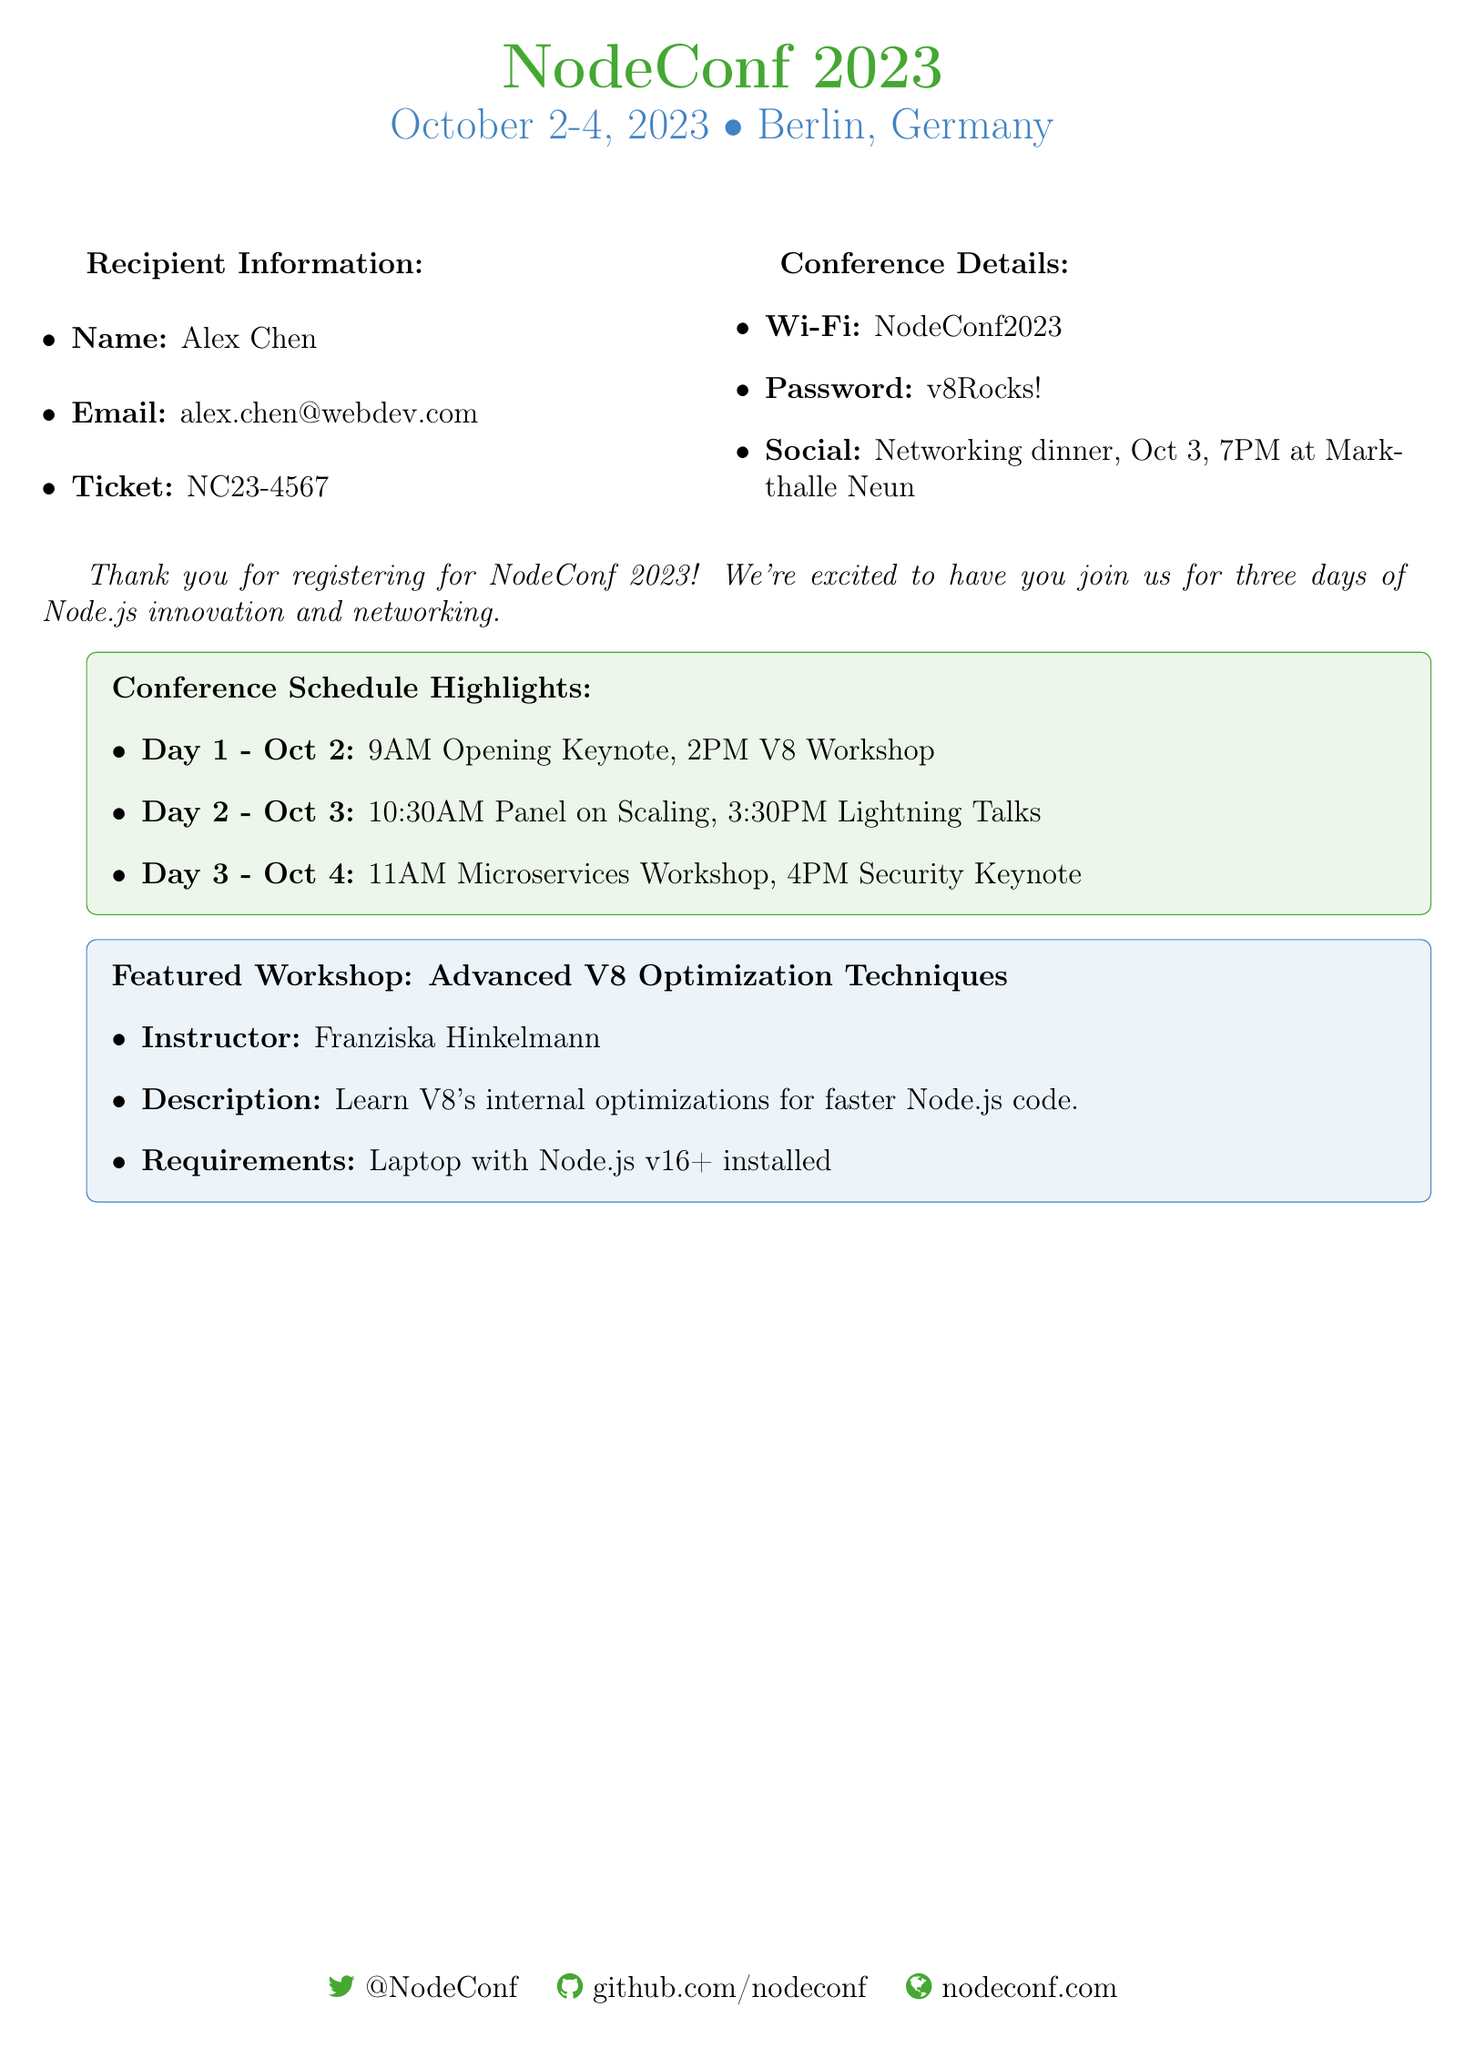What are the dates of the conference? The dates of the conference are explicitly stated at the top of the document as October 2-4, 2023.
Answer: October 2-4, 2023 What is the recipient's email address? The email address of the recipient is listed in the recipient information section.
Answer: alex.chen@webdev.com What is the ticket number? The ticket number for the recipient is clearly mentioned in the document.
Answer: NC23-4567 What is the name of the workshop featured? The document mentions the featured workshop as "Advanced V8 Optimization Techniques".
Answer: Advanced V8 Optimization Techniques Who is the instructor for the workshop? The instructor's name is provided in the workshop details within the document.
Answer: Franziska Hinkelmann What time does the opening keynote start? The schedule highlights indicate that the opening keynote starts at 9 AM on the first day.
Answer: 9 AM What is the password for the Wi-Fi? The Wi-Fi password is specified in the conference details section of the document.
Answer: v8Rocks! What is scheduled for October 4, 2023? The document lists a "Security Keynote" scheduled at 4 PM on that day.
Answer: Security Keynote What is the location of the networking dinner? The networking dinner's location is clearly stated in the document as "Markthalle Neun".
Answer: Markthalle Neun 